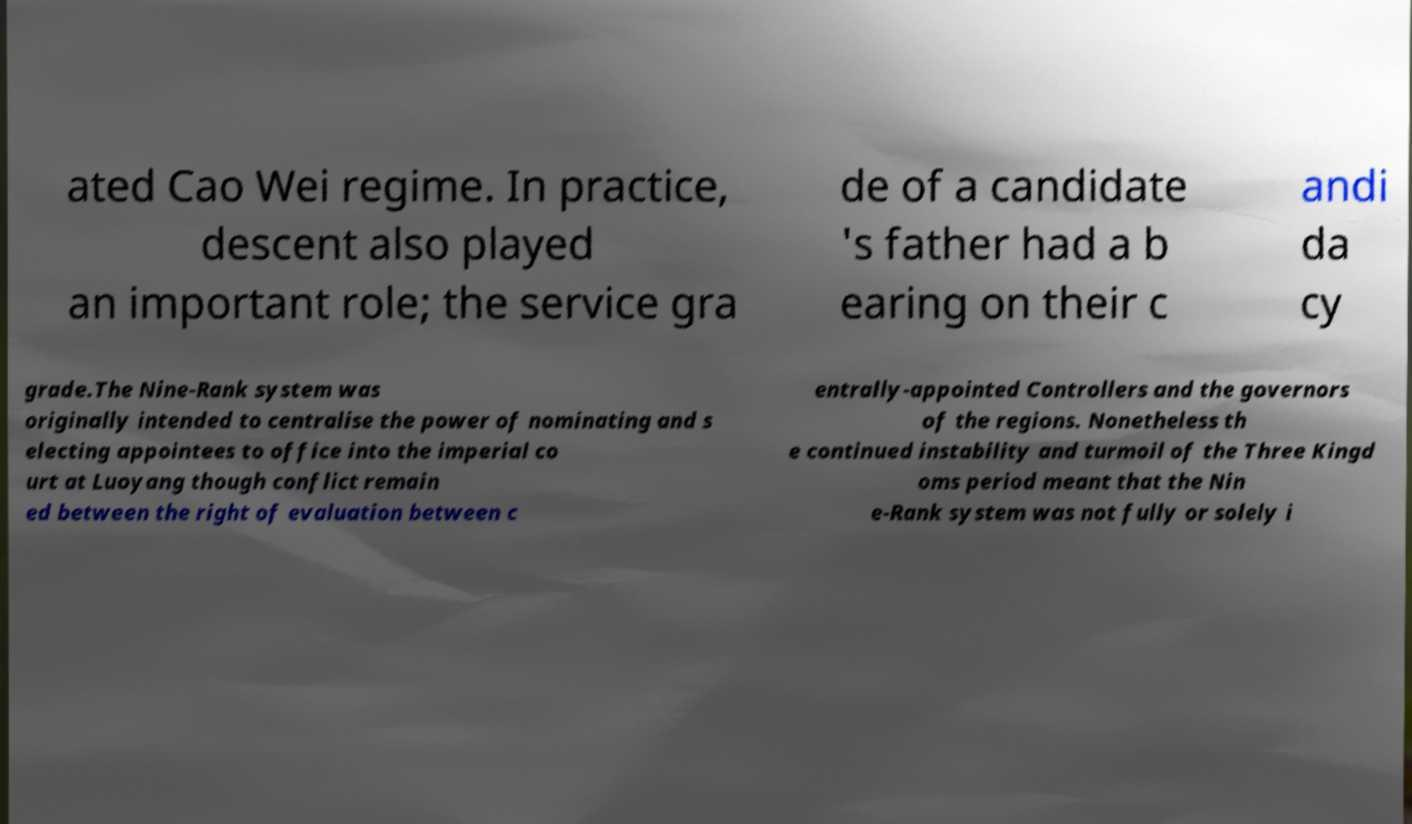What messages or text are displayed in this image? I need them in a readable, typed format. ated Cao Wei regime. In practice, descent also played an important role; the service gra de of a candidate 's father had a b earing on their c andi da cy grade.The Nine-Rank system was originally intended to centralise the power of nominating and s electing appointees to office into the imperial co urt at Luoyang though conflict remain ed between the right of evaluation between c entrally-appointed Controllers and the governors of the regions. Nonetheless th e continued instability and turmoil of the Three Kingd oms period meant that the Nin e-Rank system was not fully or solely i 